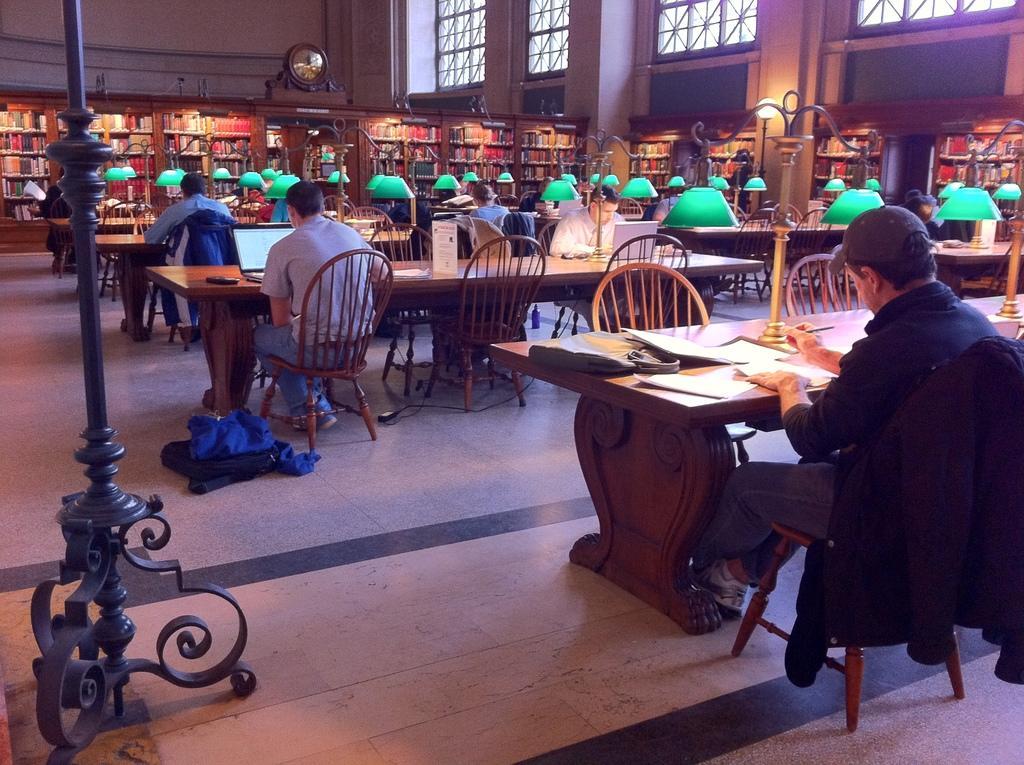Please provide a concise description of this image. Here we can see people sitting on chairs with tables in front of them with some of them operating laptops and some of them having books in front of them and around them we can see bookshelves present and there are big big windows as we can see on the right side and this this is probably is looking like a library and there are lamps present on each table 